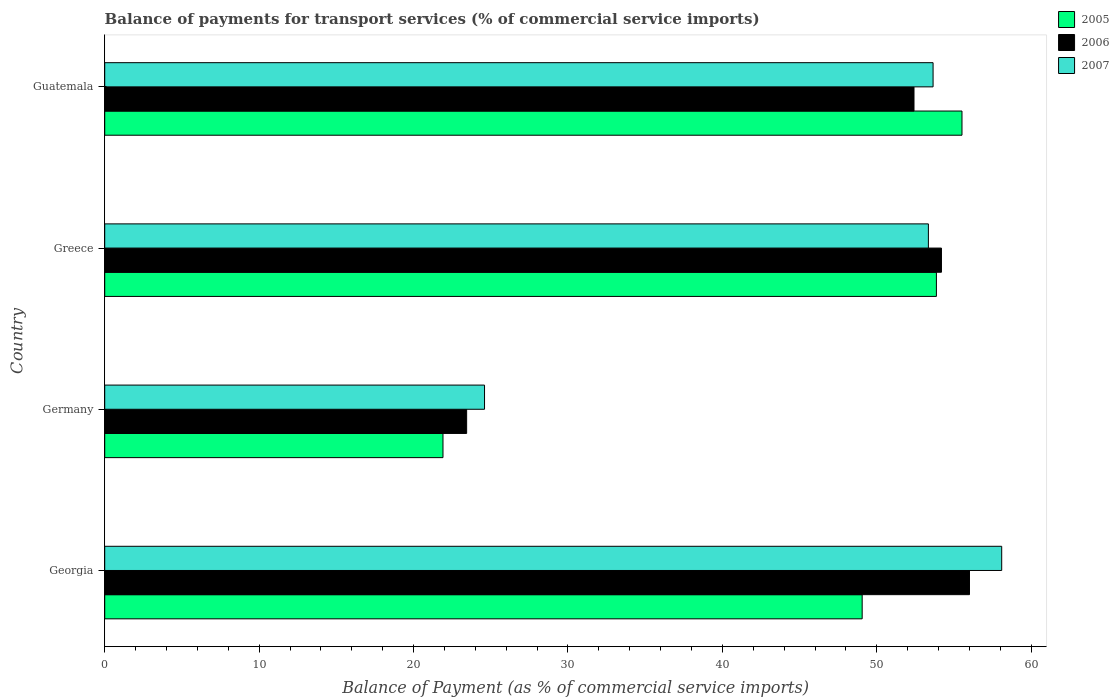How many different coloured bars are there?
Ensure brevity in your answer.  3. How many groups of bars are there?
Offer a terse response. 4. How many bars are there on the 3rd tick from the bottom?
Your response must be concise. 3. In how many cases, is the number of bars for a given country not equal to the number of legend labels?
Give a very brief answer. 0. What is the balance of payments for transport services in 2006 in Guatemala?
Your answer should be compact. 52.41. Across all countries, what is the maximum balance of payments for transport services in 2005?
Offer a very short reply. 55.52. Across all countries, what is the minimum balance of payments for transport services in 2006?
Provide a succinct answer. 23.44. In which country was the balance of payments for transport services in 2006 maximum?
Give a very brief answer. Georgia. What is the total balance of payments for transport services in 2005 in the graph?
Ensure brevity in your answer.  180.33. What is the difference between the balance of payments for transport services in 2007 in Georgia and that in Greece?
Your response must be concise. 4.75. What is the difference between the balance of payments for transport services in 2005 in Greece and the balance of payments for transport services in 2007 in Georgia?
Provide a short and direct response. -4.23. What is the average balance of payments for transport services in 2005 per country?
Give a very brief answer. 45.08. What is the difference between the balance of payments for transport services in 2006 and balance of payments for transport services in 2007 in Greece?
Ensure brevity in your answer.  0.85. In how many countries, is the balance of payments for transport services in 2005 greater than 52 %?
Make the answer very short. 2. What is the ratio of the balance of payments for transport services in 2006 in Greece to that in Guatemala?
Offer a very short reply. 1.03. Is the difference between the balance of payments for transport services in 2006 in Georgia and Greece greater than the difference between the balance of payments for transport services in 2007 in Georgia and Greece?
Ensure brevity in your answer.  No. What is the difference between the highest and the second highest balance of payments for transport services in 2007?
Your response must be concise. 4.44. What is the difference between the highest and the lowest balance of payments for transport services in 2006?
Your response must be concise. 32.56. What does the 1st bar from the bottom in Germany represents?
Offer a terse response. 2005. How many bars are there?
Your answer should be very brief. 12. What is the difference between two consecutive major ticks on the X-axis?
Keep it short and to the point. 10. Where does the legend appear in the graph?
Keep it short and to the point. Top right. What is the title of the graph?
Provide a short and direct response. Balance of payments for transport services (% of commercial service imports). What is the label or title of the X-axis?
Offer a very short reply. Balance of Payment (as % of commercial service imports). What is the Balance of Payment (as % of commercial service imports) of 2005 in Georgia?
Your answer should be very brief. 49.05. What is the Balance of Payment (as % of commercial service imports) of 2006 in Georgia?
Your answer should be very brief. 56. What is the Balance of Payment (as % of commercial service imports) of 2007 in Georgia?
Make the answer very short. 58.09. What is the Balance of Payment (as % of commercial service imports) in 2005 in Germany?
Offer a very short reply. 21.91. What is the Balance of Payment (as % of commercial service imports) in 2006 in Germany?
Your answer should be very brief. 23.44. What is the Balance of Payment (as % of commercial service imports) of 2007 in Germany?
Provide a short and direct response. 24.6. What is the Balance of Payment (as % of commercial service imports) of 2005 in Greece?
Provide a short and direct response. 53.86. What is the Balance of Payment (as % of commercial service imports) in 2006 in Greece?
Make the answer very short. 54.19. What is the Balance of Payment (as % of commercial service imports) in 2007 in Greece?
Your response must be concise. 53.34. What is the Balance of Payment (as % of commercial service imports) in 2005 in Guatemala?
Offer a very short reply. 55.52. What is the Balance of Payment (as % of commercial service imports) of 2006 in Guatemala?
Provide a succinct answer. 52.41. What is the Balance of Payment (as % of commercial service imports) of 2007 in Guatemala?
Make the answer very short. 53.64. Across all countries, what is the maximum Balance of Payment (as % of commercial service imports) in 2005?
Offer a terse response. 55.52. Across all countries, what is the maximum Balance of Payment (as % of commercial service imports) of 2006?
Make the answer very short. 56. Across all countries, what is the maximum Balance of Payment (as % of commercial service imports) in 2007?
Your answer should be compact. 58.09. Across all countries, what is the minimum Balance of Payment (as % of commercial service imports) of 2005?
Provide a succinct answer. 21.91. Across all countries, what is the minimum Balance of Payment (as % of commercial service imports) in 2006?
Your response must be concise. 23.44. Across all countries, what is the minimum Balance of Payment (as % of commercial service imports) in 2007?
Provide a succinct answer. 24.6. What is the total Balance of Payment (as % of commercial service imports) of 2005 in the graph?
Offer a terse response. 180.33. What is the total Balance of Payment (as % of commercial service imports) of 2006 in the graph?
Provide a succinct answer. 186.03. What is the total Balance of Payment (as % of commercial service imports) of 2007 in the graph?
Offer a terse response. 189.67. What is the difference between the Balance of Payment (as % of commercial service imports) of 2005 in Georgia and that in Germany?
Your answer should be very brief. 27.15. What is the difference between the Balance of Payment (as % of commercial service imports) in 2006 in Georgia and that in Germany?
Your response must be concise. 32.56. What is the difference between the Balance of Payment (as % of commercial service imports) in 2007 in Georgia and that in Germany?
Provide a succinct answer. 33.49. What is the difference between the Balance of Payment (as % of commercial service imports) in 2005 in Georgia and that in Greece?
Your answer should be compact. -4.81. What is the difference between the Balance of Payment (as % of commercial service imports) of 2006 in Georgia and that in Greece?
Your response must be concise. 1.82. What is the difference between the Balance of Payment (as % of commercial service imports) in 2007 in Georgia and that in Greece?
Keep it short and to the point. 4.75. What is the difference between the Balance of Payment (as % of commercial service imports) in 2005 in Georgia and that in Guatemala?
Offer a terse response. -6.46. What is the difference between the Balance of Payment (as % of commercial service imports) in 2006 in Georgia and that in Guatemala?
Ensure brevity in your answer.  3.59. What is the difference between the Balance of Payment (as % of commercial service imports) in 2007 in Georgia and that in Guatemala?
Make the answer very short. 4.44. What is the difference between the Balance of Payment (as % of commercial service imports) of 2005 in Germany and that in Greece?
Make the answer very short. -31.95. What is the difference between the Balance of Payment (as % of commercial service imports) in 2006 in Germany and that in Greece?
Your answer should be compact. -30.75. What is the difference between the Balance of Payment (as % of commercial service imports) in 2007 in Germany and that in Greece?
Give a very brief answer. -28.74. What is the difference between the Balance of Payment (as % of commercial service imports) of 2005 in Germany and that in Guatemala?
Ensure brevity in your answer.  -33.61. What is the difference between the Balance of Payment (as % of commercial service imports) in 2006 in Germany and that in Guatemala?
Ensure brevity in your answer.  -28.97. What is the difference between the Balance of Payment (as % of commercial service imports) of 2007 in Germany and that in Guatemala?
Your answer should be very brief. -29.05. What is the difference between the Balance of Payment (as % of commercial service imports) of 2005 in Greece and that in Guatemala?
Make the answer very short. -1.66. What is the difference between the Balance of Payment (as % of commercial service imports) in 2006 in Greece and that in Guatemala?
Your answer should be compact. 1.78. What is the difference between the Balance of Payment (as % of commercial service imports) of 2007 in Greece and that in Guatemala?
Provide a short and direct response. -0.3. What is the difference between the Balance of Payment (as % of commercial service imports) of 2005 in Georgia and the Balance of Payment (as % of commercial service imports) of 2006 in Germany?
Give a very brief answer. 25.61. What is the difference between the Balance of Payment (as % of commercial service imports) of 2005 in Georgia and the Balance of Payment (as % of commercial service imports) of 2007 in Germany?
Provide a succinct answer. 24.46. What is the difference between the Balance of Payment (as % of commercial service imports) of 2006 in Georgia and the Balance of Payment (as % of commercial service imports) of 2007 in Germany?
Give a very brief answer. 31.4. What is the difference between the Balance of Payment (as % of commercial service imports) in 2005 in Georgia and the Balance of Payment (as % of commercial service imports) in 2006 in Greece?
Offer a terse response. -5.13. What is the difference between the Balance of Payment (as % of commercial service imports) of 2005 in Georgia and the Balance of Payment (as % of commercial service imports) of 2007 in Greece?
Keep it short and to the point. -4.29. What is the difference between the Balance of Payment (as % of commercial service imports) in 2006 in Georgia and the Balance of Payment (as % of commercial service imports) in 2007 in Greece?
Provide a short and direct response. 2.66. What is the difference between the Balance of Payment (as % of commercial service imports) of 2005 in Georgia and the Balance of Payment (as % of commercial service imports) of 2006 in Guatemala?
Provide a short and direct response. -3.36. What is the difference between the Balance of Payment (as % of commercial service imports) in 2005 in Georgia and the Balance of Payment (as % of commercial service imports) in 2007 in Guatemala?
Keep it short and to the point. -4.59. What is the difference between the Balance of Payment (as % of commercial service imports) of 2006 in Georgia and the Balance of Payment (as % of commercial service imports) of 2007 in Guatemala?
Offer a terse response. 2.36. What is the difference between the Balance of Payment (as % of commercial service imports) in 2005 in Germany and the Balance of Payment (as % of commercial service imports) in 2006 in Greece?
Provide a succinct answer. -32.28. What is the difference between the Balance of Payment (as % of commercial service imports) in 2005 in Germany and the Balance of Payment (as % of commercial service imports) in 2007 in Greece?
Ensure brevity in your answer.  -31.43. What is the difference between the Balance of Payment (as % of commercial service imports) in 2006 in Germany and the Balance of Payment (as % of commercial service imports) in 2007 in Greece?
Your answer should be very brief. -29.9. What is the difference between the Balance of Payment (as % of commercial service imports) in 2005 in Germany and the Balance of Payment (as % of commercial service imports) in 2006 in Guatemala?
Keep it short and to the point. -30.5. What is the difference between the Balance of Payment (as % of commercial service imports) of 2005 in Germany and the Balance of Payment (as % of commercial service imports) of 2007 in Guatemala?
Ensure brevity in your answer.  -31.74. What is the difference between the Balance of Payment (as % of commercial service imports) in 2006 in Germany and the Balance of Payment (as % of commercial service imports) in 2007 in Guatemala?
Offer a terse response. -30.21. What is the difference between the Balance of Payment (as % of commercial service imports) of 2005 in Greece and the Balance of Payment (as % of commercial service imports) of 2006 in Guatemala?
Offer a very short reply. 1.45. What is the difference between the Balance of Payment (as % of commercial service imports) of 2005 in Greece and the Balance of Payment (as % of commercial service imports) of 2007 in Guatemala?
Your answer should be compact. 0.22. What is the difference between the Balance of Payment (as % of commercial service imports) of 2006 in Greece and the Balance of Payment (as % of commercial service imports) of 2007 in Guatemala?
Your response must be concise. 0.54. What is the average Balance of Payment (as % of commercial service imports) of 2005 per country?
Make the answer very short. 45.08. What is the average Balance of Payment (as % of commercial service imports) in 2006 per country?
Your answer should be very brief. 46.51. What is the average Balance of Payment (as % of commercial service imports) in 2007 per country?
Give a very brief answer. 47.42. What is the difference between the Balance of Payment (as % of commercial service imports) of 2005 and Balance of Payment (as % of commercial service imports) of 2006 in Georgia?
Offer a very short reply. -6.95. What is the difference between the Balance of Payment (as % of commercial service imports) of 2005 and Balance of Payment (as % of commercial service imports) of 2007 in Georgia?
Provide a succinct answer. -9.04. What is the difference between the Balance of Payment (as % of commercial service imports) in 2006 and Balance of Payment (as % of commercial service imports) in 2007 in Georgia?
Your response must be concise. -2.09. What is the difference between the Balance of Payment (as % of commercial service imports) of 2005 and Balance of Payment (as % of commercial service imports) of 2006 in Germany?
Provide a short and direct response. -1.53. What is the difference between the Balance of Payment (as % of commercial service imports) in 2005 and Balance of Payment (as % of commercial service imports) in 2007 in Germany?
Offer a very short reply. -2.69. What is the difference between the Balance of Payment (as % of commercial service imports) of 2006 and Balance of Payment (as % of commercial service imports) of 2007 in Germany?
Give a very brief answer. -1.16. What is the difference between the Balance of Payment (as % of commercial service imports) in 2005 and Balance of Payment (as % of commercial service imports) in 2006 in Greece?
Offer a very short reply. -0.33. What is the difference between the Balance of Payment (as % of commercial service imports) in 2005 and Balance of Payment (as % of commercial service imports) in 2007 in Greece?
Your answer should be very brief. 0.52. What is the difference between the Balance of Payment (as % of commercial service imports) in 2006 and Balance of Payment (as % of commercial service imports) in 2007 in Greece?
Keep it short and to the point. 0.85. What is the difference between the Balance of Payment (as % of commercial service imports) in 2005 and Balance of Payment (as % of commercial service imports) in 2006 in Guatemala?
Keep it short and to the point. 3.11. What is the difference between the Balance of Payment (as % of commercial service imports) of 2005 and Balance of Payment (as % of commercial service imports) of 2007 in Guatemala?
Provide a succinct answer. 1.87. What is the difference between the Balance of Payment (as % of commercial service imports) of 2006 and Balance of Payment (as % of commercial service imports) of 2007 in Guatemala?
Your answer should be very brief. -1.24. What is the ratio of the Balance of Payment (as % of commercial service imports) in 2005 in Georgia to that in Germany?
Provide a succinct answer. 2.24. What is the ratio of the Balance of Payment (as % of commercial service imports) in 2006 in Georgia to that in Germany?
Keep it short and to the point. 2.39. What is the ratio of the Balance of Payment (as % of commercial service imports) in 2007 in Georgia to that in Germany?
Offer a terse response. 2.36. What is the ratio of the Balance of Payment (as % of commercial service imports) of 2005 in Georgia to that in Greece?
Offer a terse response. 0.91. What is the ratio of the Balance of Payment (as % of commercial service imports) in 2006 in Georgia to that in Greece?
Offer a terse response. 1.03. What is the ratio of the Balance of Payment (as % of commercial service imports) of 2007 in Georgia to that in Greece?
Your answer should be compact. 1.09. What is the ratio of the Balance of Payment (as % of commercial service imports) of 2005 in Georgia to that in Guatemala?
Your answer should be very brief. 0.88. What is the ratio of the Balance of Payment (as % of commercial service imports) in 2006 in Georgia to that in Guatemala?
Keep it short and to the point. 1.07. What is the ratio of the Balance of Payment (as % of commercial service imports) of 2007 in Georgia to that in Guatemala?
Offer a very short reply. 1.08. What is the ratio of the Balance of Payment (as % of commercial service imports) in 2005 in Germany to that in Greece?
Your response must be concise. 0.41. What is the ratio of the Balance of Payment (as % of commercial service imports) of 2006 in Germany to that in Greece?
Keep it short and to the point. 0.43. What is the ratio of the Balance of Payment (as % of commercial service imports) of 2007 in Germany to that in Greece?
Make the answer very short. 0.46. What is the ratio of the Balance of Payment (as % of commercial service imports) in 2005 in Germany to that in Guatemala?
Offer a terse response. 0.39. What is the ratio of the Balance of Payment (as % of commercial service imports) in 2006 in Germany to that in Guatemala?
Ensure brevity in your answer.  0.45. What is the ratio of the Balance of Payment (as % of commercial service imports) of 2007 in Germany to that in Guatemala?
Your answer should be compact. 0.46. What is the ratio of the Balance of Payment (as % of commercial service imports) of 2005 in Greece to that in Guatemala?
Keep it short and to the point. 0.97. What is the ratio of the Balance of Payment (as % of commercial service imports) of 2006 in Greece to that in Guatemala?
Your response must be concise. 1.03. What is the difference between the highest and the second highest Balance of Payment (as % of commercial service imports) of 2005?
Offer a terse response. 1.66. What is the difference between the highest and the second highest Balance of Payment (as % of commercial service imports) of 2006?
Your answer should be compact. 1.82. What is the difference between the highest and the second highest Balance of Payment (as % of commercial service imports) in 2007?
Give a very brief answer. 4.44. What is the difference between the highest and the lowest Balance of Payment (as % of commercial service imports) of 2005?
Your answer should be compact. 33.61. What is the difference between the highest and the lowest Balance of Payment (as % of commercial service imports) of 2006?
Your answer should be very brief. 32.56. What is the difference between the highest and the lowest Balance of Payment (as % of commercial service imports) of 2007?
Offer a very short reply. 33.49. 